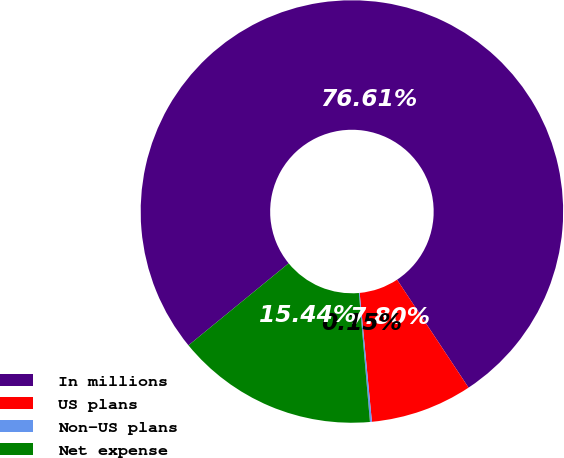Convert chart to OTSL. <chart><loc_0><loc_0><loc_500><loc_500><pie_chart><fcel>In millions<fcel>US plans<fcel>Non-US plans<fcel>Net expense<nl><fcel>76.61%<fcel>7.8%<fcel>0.15%<fcel>15.44%<nl></chart> 